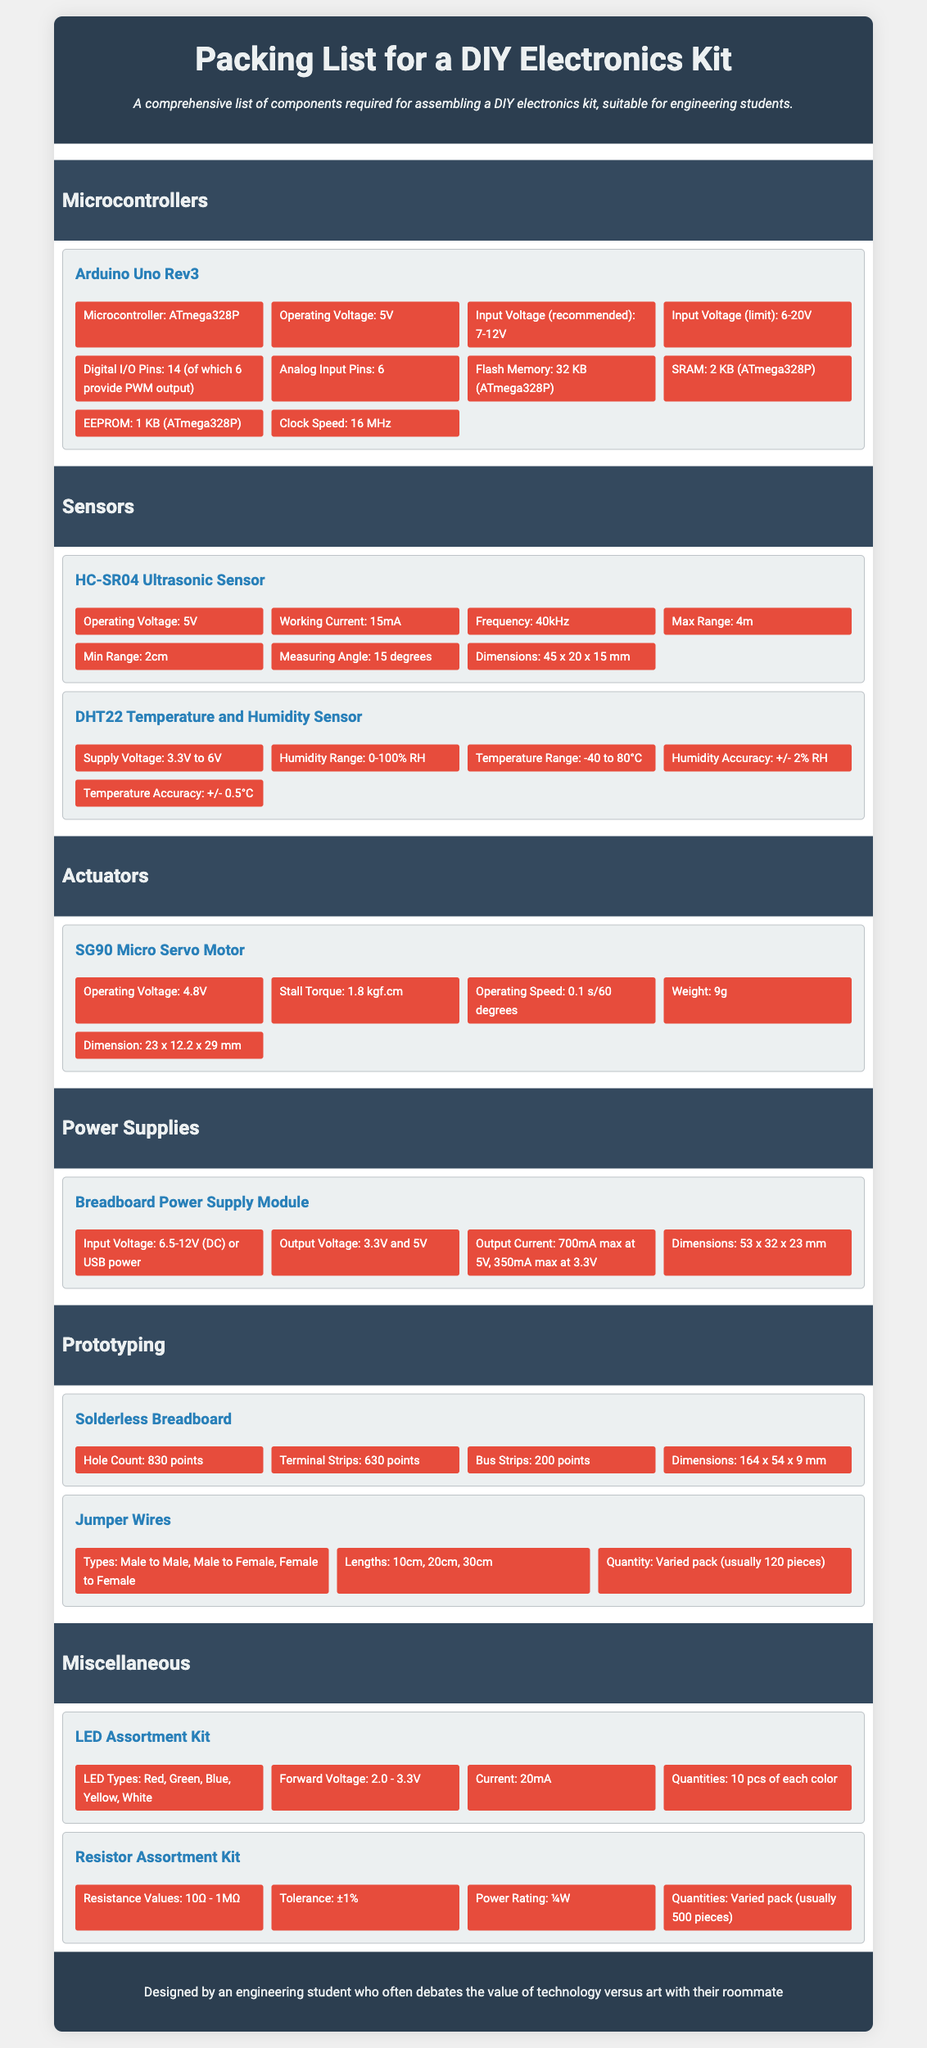What is the microcontroller used in Arduino Uno Rev3? The microcontroller used in Arduino Uno Rev3 is specified in the document under the component details.
Answer: ATmega328P What is the operating voltage of the HC-SR04 Ultrasonic Sensor? The operating voltage is listed in the specifications of the HC-SR04 component in the document.
Answer: 5V How many digital I/O pins does the Arduino Uno have? This information is retrieved from the specifications section of the Arduino Uno component.
Answer: 14 What is the measuring angle of the HC-SR04 Ultrasonic Sensor? The measuring angle is given in the details provided for the HC-SR04 component.
Answer: 15 degrees What operating voltage is required for the SG90 Micro Servo Motor? The operating voltage is mentioned under the SG90 component specifications in the document.
Answer: 4.8V How many points does the solderless breadboard have? The hole count is specified in the component details of the solderless breadboard.
Answer: 830 points What types of jumper wires are included in the kit? The types of jumper wires are mentioned in their respective component specifications.
Answer: Male to Male, Male to Female, Female to Female What is the forward voltage range of the LED Assortment Kit? The forward voltage range is detailed in the specs of the LED Assortment Kit.
Answer: 2.0 - 3.3V How many pieces are usually included in the resistor assortment kit? The quantity is specified in the component details of the resistor assortment kit.
Answer: 500 pieces 